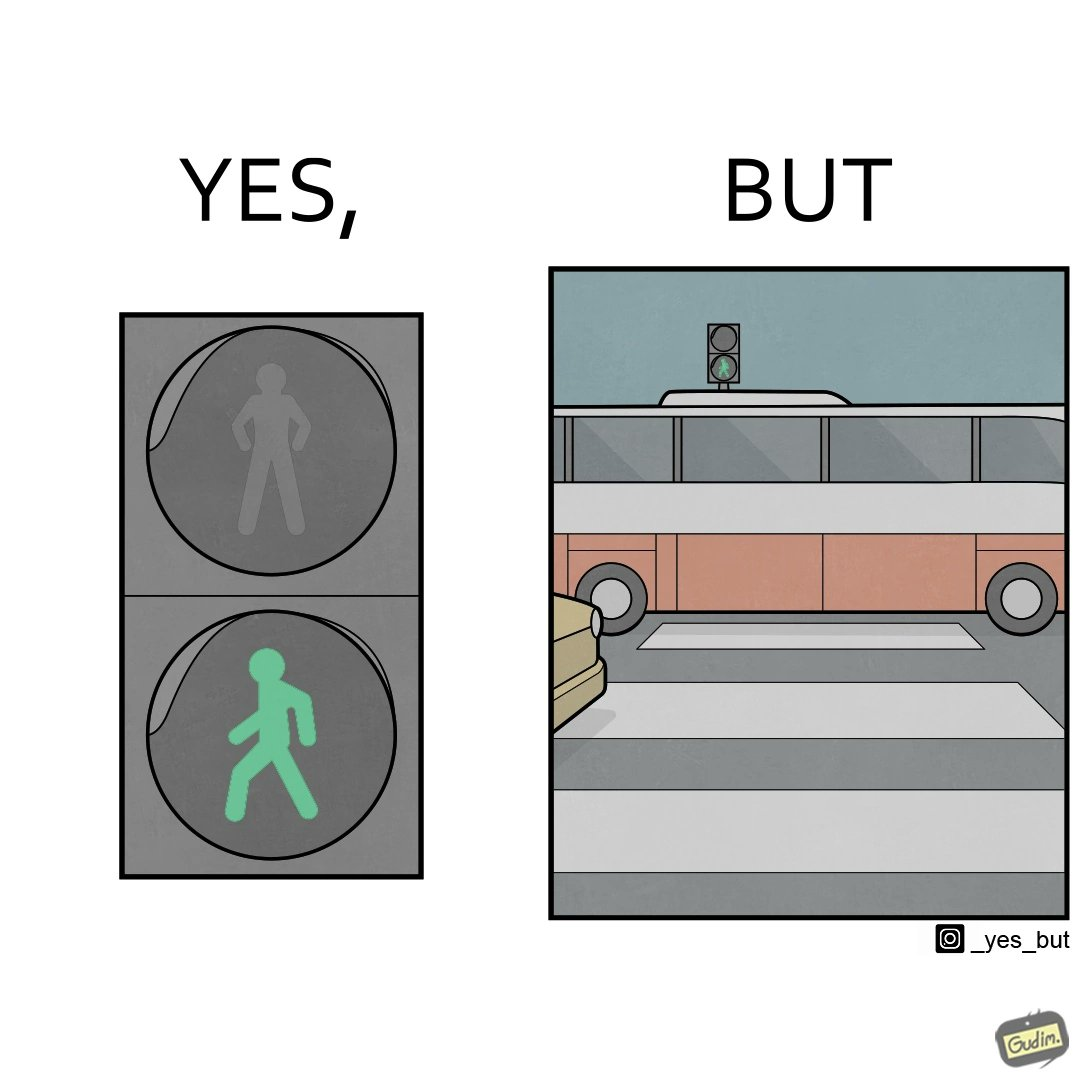What is shown in this image? The image is ironic, because even when the signal is green for the pedestrians but they can't cross the road because of the vehicles standing on the zebra crossing 